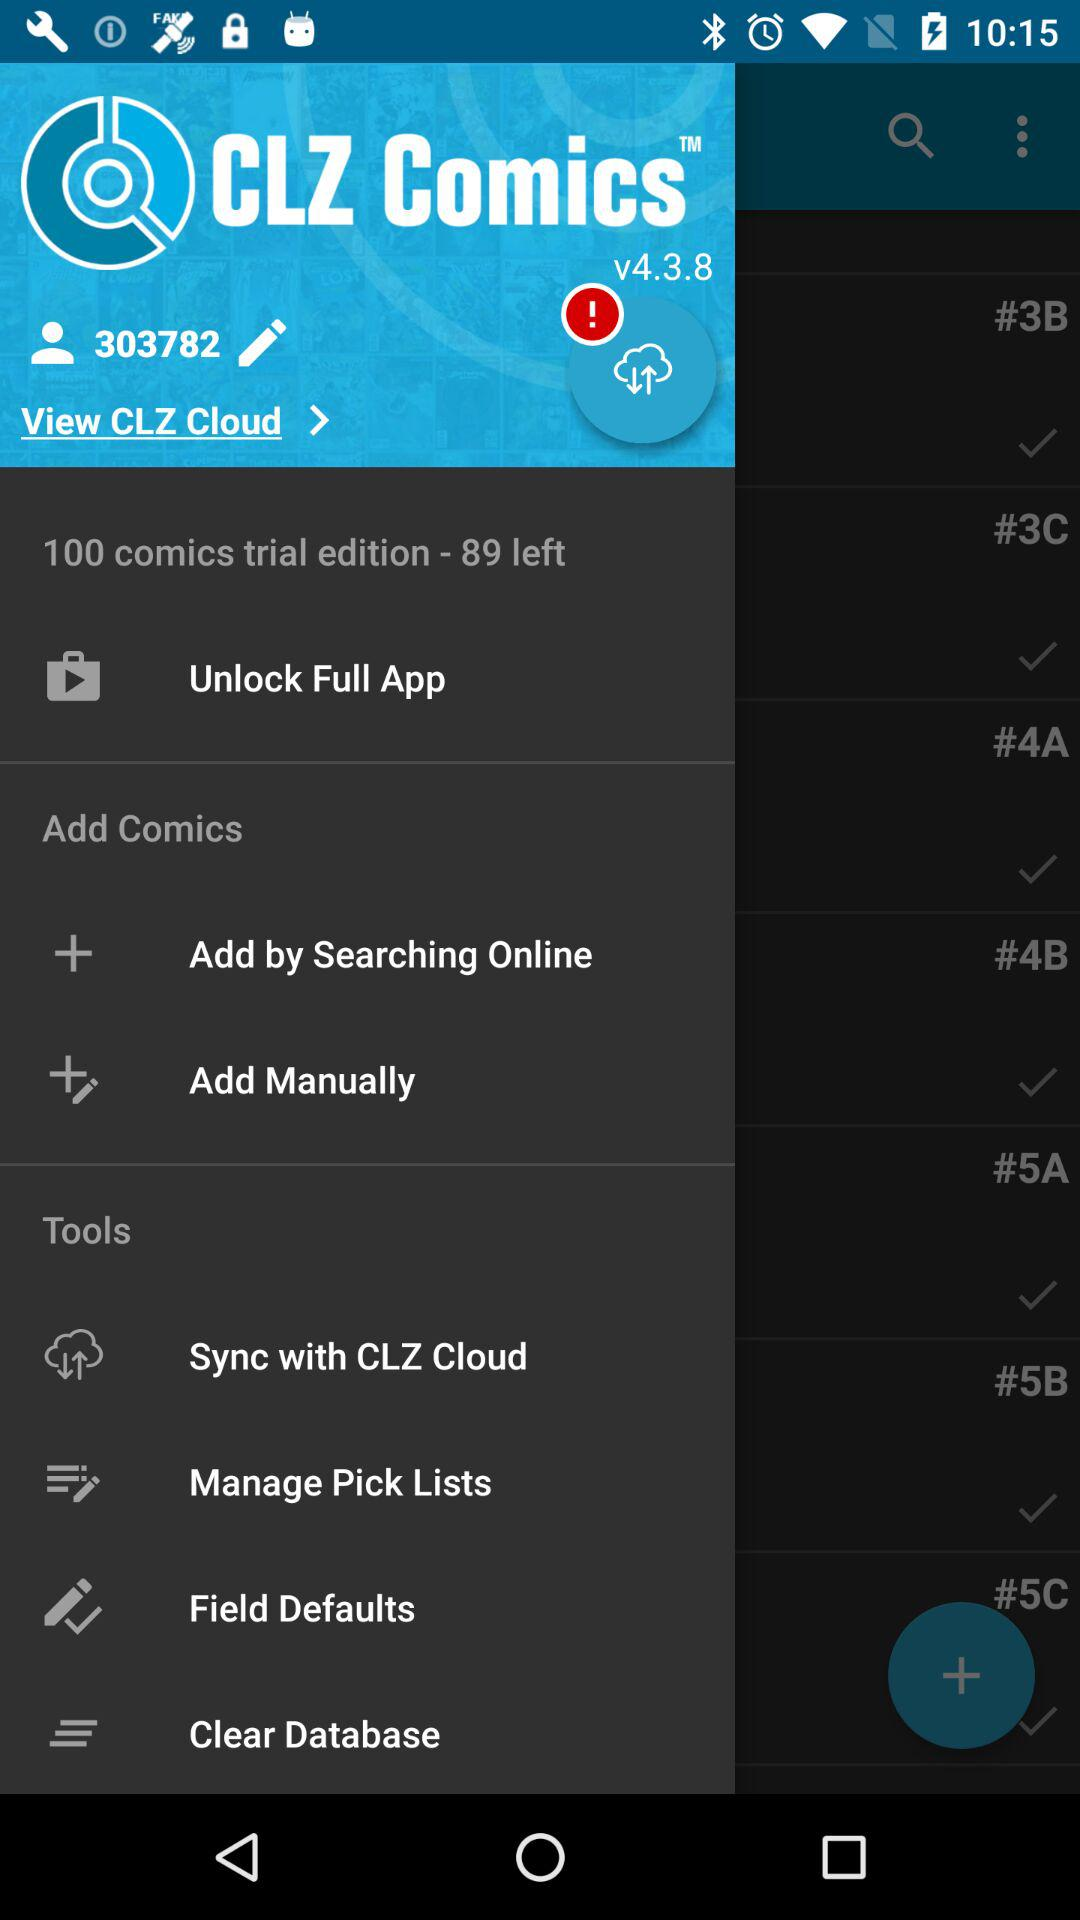What is the version of the application? The version of the application is v4.3.8. 